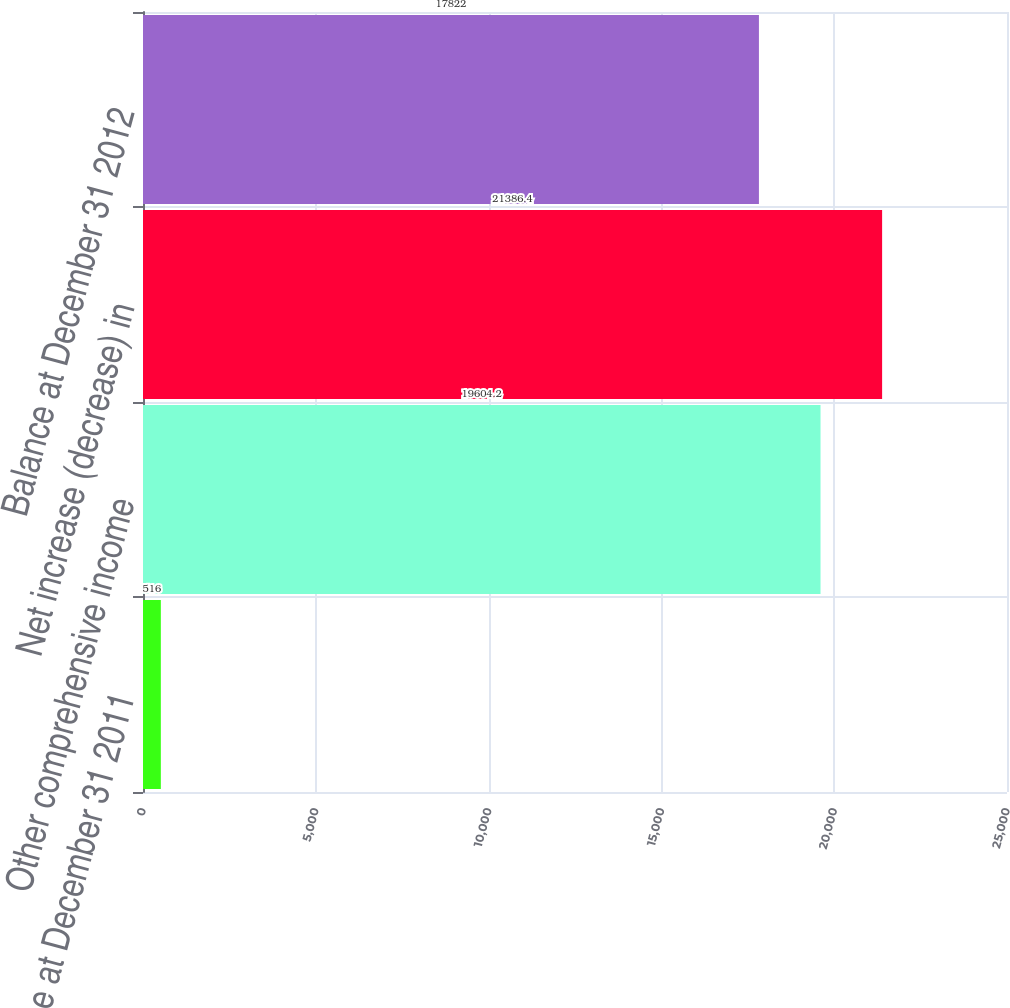Convert chart. <chart><loc_0><loc_0><loc_500><loc_500><bar_chart><fcel>Balance at December 31 2011<fcel>Other comprehensive income<fcel>Net increase (decrease) in<fcel>Balance at December 31 2012<nl><fcel>516<fcel>19604.2<fcel>21386.4<fcel>17822<nl></chart> 